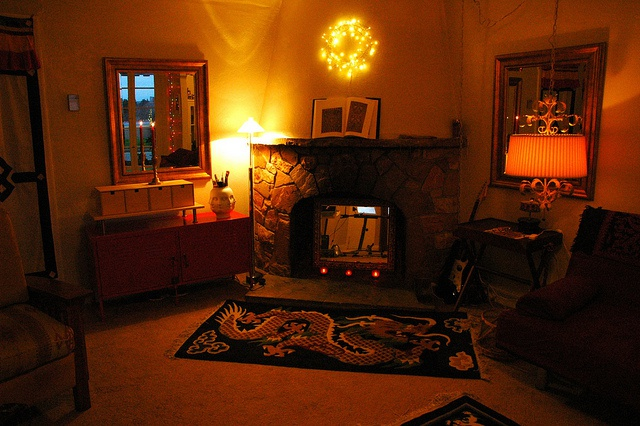Describe the objects in this image and their specific colors. I can see chair in black and maroon tones, couch in black and maroon tones, tv in maroon, black, and brown tones, book in maroon, brown, and black tones, and vase in maroon, red, and brown tones in this image. 